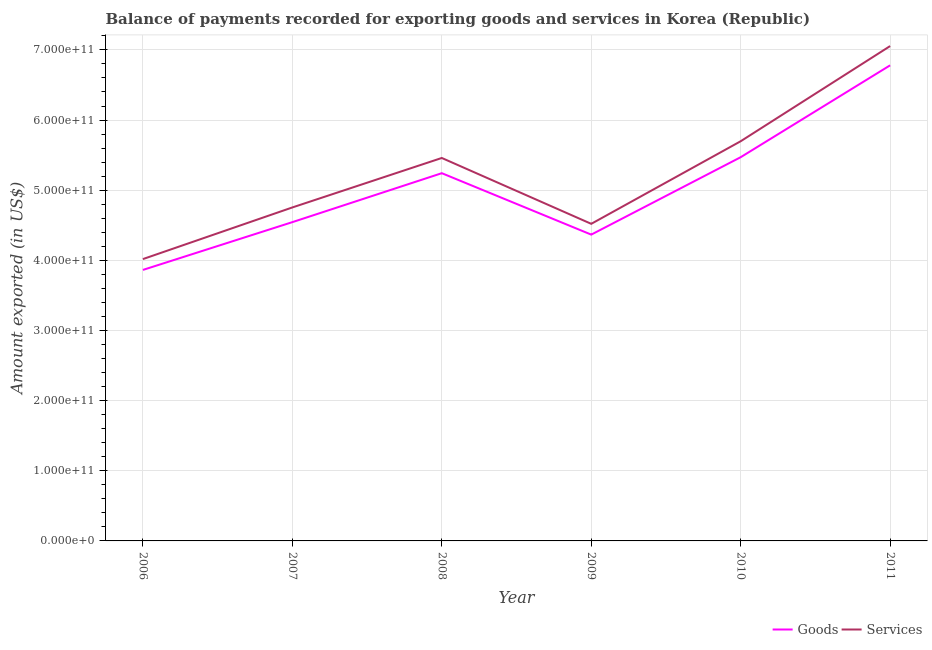Is the number of lines equal to the number of legend labels?
Your answer should be very brief. Yes. What is the amount of goods exported in 2008?
Your answer should be very brief. 5.24e+11. Across all years, what is the maximum amount of services exported?
Your response must be concise. 7.05e+11. Across all years, what is the minimum amount of services exported?
Provide a succinct answer. 4.02e+11. What is the total amount of services exported in the graph?
Your answer should be very brief. 3.15e+12. What is the difference between the amount of services exported in 2008 and that in 2011?
Your answer should be compact. -1.60e+11. What is the difference between the amount of services exported in 2010 and the amount of goods exported in 2009?
Give a very brief answer. 1.33e+11. What is the average amount of goods exported per year?
Make the answer very short. 5.04e+11. In the year 2006, what is the difference between the amount of services exported and amount of goods exported?
Offer a terse response. 1.55e+1. What is the ratio of the amount of services exported in 2006 to that in 2011?
Keep it short and to the point. 0.57. Is the difference between the amount of services exported in 2006 and 2009 greater than the difference between the amount of goods exported in 2006 and 2009?
Your answer should be very brief. Yes. What is the difference between the highest and the second highest amount of services exported?
Give a very brief answer. 1.36e+11. What is the difference between the highest and the lowest amount of goods exported?
Keep it short and to the point. 2.92e+11. In how many years, is the amount of goods exported greater than the average amount of goods exported taken over all years?
Provide a short and direct response. 3. Is the sum of the amount of goods exported in 2006 and 2011 greater than the maximum amount of services exported across all years?
Ensure brevity in your answer.  Yes. How many years are there in the graph?
Ensure brevity in your answer.  6. What is the difference between two consecutive major ticks on the Y-axis?
Your answer should be compact. 1.00e+11. Are the values on the major ticks of Y-axis written in scientific E-notation?
Provide a short and direct response. Yes. Does the graph contain grids?
Provide a short and direct response. Yes. Where does the legend appear in the graph?
Provide a succinct answer. Bottom right. What is the title of the graph?
Your response must be concise. Balance of payments recorded for exporting goods and services in Korea (Republic). What is the label or title of the Y-axis?
Make the answer very short. Amount exported (in US$). What is the Amount exported (in US$) of Goods in 2006?
Provide a short and direct response. 3.86e+11. What is the Amount exported (in US$) of Services in 2006?
Give a very brief answer. 4.02e+11. What is the Amount exported (in US$) of Goods in 2007?
Give a very brief answer. 4.54e+11. What is the Amount exported (in US$) of Services in 2007?
Provide a succinct answer. 4.75e+11. What is the Amount exported (in US$) in Goods in 2008?
Your response must be concise. 5.24e+11. What is the Amount exported (in US$) of Services in 2008?
Provide a short and direct response. 5.46e+11. What is the Amount exported (in US$) of Goods in 2009?
Make the answer very short. 4.37e+11. What is the Amount exported (in US$) of Services in 2009?
Keep it short and to the point. 4.52e+11. What is the Amount exported (in US$) of Goods in 2010?
Your response must be concise. 5.47e+11. What is the Amount exported (in US$) of Services in 2010?
Offer a terse response. 5.70e+11. What is the Amount exported (in US$) of Goods in 2011?
Provide a short and direct response. 6.78e+11. What is the Amount exported (in US$) in Services in 2011?
Keep it short and to the point. 7.05e+11. Across all years, what is the maximum Amount exported (in US$) of Goods?
Give a very brief answer. 6.78e+11. Across all years, what is the maximum Amount exported (in US$) in Services?
Offer a very short reply. 7.05e+11. Across all years, what is the minimum Amount exported (in US$) of Goods?
Your response must be concise. 3.86e+11. Across all years, what is the minimum Amount exported (in US$) of Services?
Offer a very short reply. 4.02e+11. What is the total Amount exported (in US$) of Goods in the graph?
Your response must be concise. 3.03e+12. What is the total Amount exported (in US$) in Services in the graph?
Keep it short and to the point. 3.15e+12. What is the difference between the Amount exported (in US$) in Goods in 2006 and that in 2007?
Your response must be concise. -6.81e+1. What is the difference between the Amount exported (in US$) of Services in 2006 and that in 2007?
Offer a very short reply. -7.36e+1. What is the difference between the Amount exported (in US$) in Goods in 2006 and that in 2008?
Keep it short and to the point. -1.38e+11. What is the difference between the Amount exported (in US$) in Services in 2006 and that in 2008?
Your answer should be compact. -1.44e+11. What is the difference between the Amount exported (in US$) in Goods in 2006 and that in 2009?
Provide a succinct answer. -5.03e+1. What is the difference between the Amount exported (in US$) of Services in 2006 and that in 2009?
Your answer should be compact. -5.03e+1. What is the difference between the Amount exported (in US$) of Goods in 2006 and that in 2010?
Offer a terse response. -1.61e+11. What is the difference between the Amount exported (in US$) in Services in 2006 and that in 2010?
Your answer should be very brief. -1.68e+11. What is the difference between the Amount exported (in US$) in Goods in 2006 and that in 2011?
Provide a short and direct response. -2.92e+11. What is the difference between the Amount exported (in US$) in Services in 2006 and that in 2011?
Give a very brief answer. -3.04e+11. What is the difference between the Amount exported (in US$) in Goods in 2007 and that in 2008?
Provide a short and direct response. -6.98e+1. What is the difference between the Amount exported (in US$) in Services in 2007 and that in 2008?
Offer a very short reply. -7.05e+1. What is the difference between the Amount exported (in US$) in Goods in 2007 and that in 2009?
Offer a terse response. 1.78e+1. What is the difference between the Amount exported (in US$) in Services in 2007 and that in 2009?
Keep it short and to the point. 2.34e+1. What is the difference between the Amount exported (in US$) of Goods in 2007 and that in 2010?
Provide a short and direct response. -9.26e+1. What is the difference between the Amount exported (in US$) in Services in 2007 and that in 2010?
Give a very brief answer. -9.44e+1. What is the difference between the Amount exported (in US$) of Goods in 2007 and that in 2011?
Your answer should be very brief. -2.24e+11. What is the difference between the Amount exported (in US$) in Services in 2007 and that in 2011?
Your answer should be very brief. -2.30e+11. What is the difference between the Amount exported (in US$) of Goods in 2008 and that in 2009?
Your response must be concise. 8.76e+1. What is the difference between the Amount exported (in US$) in Services in 2008 and that in 2009?
Give a very brief answer. 9.39e+1. What is the difference between the Amount exported (in US$) in Goods in 2008 and that in 2010?
Your response must be concise. -2.28e+1. What is the difference between the Amount exported (in US$) in Services in 2008 and that in 2010?
Ensure brevity in your answer.  -2.39e+1. What is the difference between the Amount exported (in US$) in Goods in 2008 and that in 2011?
Offer a terse response. -1.54e+11. What is the difference between the Amount exported (in US$) in Services in 2008 and that in 2011?
Your answer should be very brief. -1.60e+11. What is the difference between the Amount exported (in US$) of Goods in 2009 and that in 2010?
Keep it short and to the point. -1.10e+11. What is the difference between the Amount exported (in US$) of Services in 2009 and that in 2010?
Your response must be concise. -1.18e+11. What is the difference between the Amount exported (in US$) of Goods in 2009 and that in 2011?
Keep it short and to the point. -2.41e+11. What is the difference between the Amount exported (in US$) in Services in 2009 and that in 2011?
Your response must be concise. -2.53e+11. What is the difference between the Amount exported (in US$) of Goods in 2010 and that in 2011?
Offer a terse response. -1.31e+11. What is the difference between the Amount exported (in US$) in Services in 2010 and that in 2011?
Your answer should be very brief. -1.36e+11. What is the difference between the Amount exported (in US$) of Goods in 2006 and the Amount exported (in US$) of Services in 2007?
Provide a short and direct response. -8.91e+1. What is the difference between the Amount exported (in US$) in Goods in 2006 and the Amount exported (in US$) in Services in 2008?
Provide a succinct answer. -1.60e+11. What is the difference between the Amount exported (in US$) in Goods in 2006 and the Amount exported (in US$) in Services in 2009?
Your response must be concise. -6.57e+1. What is the difference between the Amount exported (in US$) in Goods in 2006 and the Amount exported (in US$) in Services in 2010?
Keep it short and to the point. -1.83e+11. What is the difference between the Amount exported (in US$) of Goods in 2006 and the Amount exported (in US$) of Services in 2011?
Ensure brevity in your answer.  -3.19e+11. What is the difference between the Amount exported (in US$) in Goods in 2007 and the Amount exported (in US$) in Services in 2008?
Your response must be concise. -9.15e+1. What is the difference between the Amount exported (in US$) of Goods in 2007 and the Amount exported (in US$) of Services in 2009?
Ensure brevity in your answer.  2.42e+09. What is the difference between the Amount exported (in US$) of Goods in 2007 and the Amount exported (in US$) of Services in 2010?
Make the answer very short. -1.15e+11. What is the difference between the Amount exported (in US$) of Goods in 2007 and the Amount exported (in US$) of Services in 2011?
Your answer should be very brief. -2.51e+11. What is the difference between the Amount exported (in US$) of Goods in 2008 and the Amount exported (in US$) of Services in 2009?
Provide a short and direct response. 7.22e+1. What is the difference between the Amount exported (in US$) of Goods in 2008 and the Amount exported (in US$) of Services in 2010?
Provide a succinct answer. -4.55e+1. What is the difference between the Amount exported (in US$) of Goods in 2008 and the Amount exported (in US$) of Services in 2011?
Offer a very short reply. -1.81e+11. What is the difference between the Amount exported (in US$) in Goods in 2009 and the Amount exported (in US$) in Services in 2010?
Provide a short and direct response. -1.33e+11. What is the difference between the Amount exported (in US$) of Goods in 2009 and the Amount exported (in US$) of Services in 2011?
Your answer should be compact. -2.69e+11. What is the difference between the Amount exported (in US$) in Goods in 2010 and the Amount exported (in US$) in Services in 2011?
Make the answer very short. -1.58e+11. What is the average Amount exported (in US$) of Goods per year?
Ensure brevity in your answer.  5.04e+11. What is the average Amount exported (in US$) in Services per year?
Offer a terse response. 5.25e+11. In the year 2006, what is the difference between the Amount exported (in US$) of Goods and Amount exported (in US$) of Services?
Your answer should be very brief. -1.55e+1. In the year 2007, what is the difference between the Amount exported (in US$) in Goods and Amount exported (in US$) in Services?
Offer a terse response. -2.09e+1. In the year 2008, what is the difference between the Amount exported (in US$) in Goods and Amount exported (in US$) in Services?
Make the answer very short. -2.17e+1. In the year 2009, what is the difference between the Amount exported (in US$) of Goods and Amount exported (in US$) of Services?
Give a very brief answer. -1.54e+1. In the year 2010, what is the difference between the Amount exported (in US$) in Goods and Amount exported (in US$) in Services?
Your answer should be compact. -2.27e+1. In the year 2011, what is the difference between the Amount exported (in US$) in Goods and Amount exported (in US$) in Services?
Provide a short and direct response. -2.74e+1. What is the ratio of the Amount exported (in US$) in Goods in 2006 to that in 2007?
Give a very brief answer. 0.85. What is the ratio of the Amount exported (in US$) in Services in 2006 to that in 2007?
Your answer should be very brief. 0.85. What is the ratio of the Amount exported (in US$) in Goods in 2006 to that in 2008?
Offer a very short reply. 0.74. What is the ratio of the Amount exported (in US$) of Services in 2006 to that in 2008?
Your answer should be compact. 0.74. What is the ratio of the Amount exported (in US$) in Goods in 2006 to that in 2009?
Offer a very short reply. 0.88. What is the ratio of the Amount exported (in US$) of Services in 2006 to that in 2009?
Offer a very short reply. 0.89. What is the ratio of the Amount exported (in US$) of Goods in 2006 to that in 2010?
Offer a terse response. 0.71. What is the ratio of the Amount exported (in US$) of Services in 2006 to that in 2010?
Offer a very short reply. 0.71. What is the ratio of the Amount exported (in US$) in Goods in 2006 to that in 2011?
Offer a terse response. 0.57. What is the ratio of the Amount exported (in US$) of Services in 2006 to that in 2011?
Offer a terse response. 0.57. What is the ratio of the Amount exported (in US$) of Goods in 2007 to that in 2008?
Your response must be concise. 0.87. What is the ratio of the Amount exported (in US$) of Services in 2007 to that in 2008?
Your answer should be compact. 0.87. What is the ratio of the Amount exported (in US$) of Goods in 2007 to that in 2009?
Your answer should be very brief. 1.04. What is the ratio of the Amount exported (in US$) in Services in 2007 to that in 2009?
Provide a succinct answer. 1.05. What is the ratio of the Amount exported (in US$) of Goods in 2007 to that in 2010?
Make the answer very short. 0.83. What is the ratio of the Amount exported (in US$) in Services in 2007 to that in 2010?
Ensure brevity in your answer.  0.83. What is the ratio of the Amount exported (in US$) of Goods in 2007 to that in 2011?
Give a very brief answer. 0.67. What is the ratio of the Amount exported (in US$) in Services in 2007 to that in 2011?
Offer a terse response. 0.67. What is the ratio of the Amount exported (in US$) of Goods in 2008 to that in 2009?
Ensure brevity in your answer.  1.2. What is the ratio of the Amount exported (in US$) in Services in 2008 to that in 2009?
Keep it short and to the point. 1.21. What is the ratio of the Amount exported (in US$) of Goods in 2008 to that in 2010?
Offer a very short reply. 0.96. What is the ratio of the Amount exported (in US$) in Services in 2008 to that in 2010?
Give a very brief answer. 0.96. What is the ratio of the Amount exported (in US$) in Goods in 2008 to that in 2011?
Give a very brief answer. 0.77. What is the ratio of the Amount exported (in US$) in Services in 2008 to that in 2011?
Offer a very short reply. 0.77. What is the ratio of the Amount exported (in US$) in Goods in 2009 to that in 2010?
Give a very brief answer. 0.8. What is the ratio of the Amount exported (in US$) in Services in 2009 to that in 2010?
Your response must be concise. 0.79. What is the ratio of the Amount exported (in US$) of Goods in 2009 to that in 2011?
Provide a succinct answer. 0.64. What is the ratio of the Amount exported (in US$) of Services in 2009 to that in 2011?
Provide a succinct answer. 0.64. What is the ratio of the Amount exported (in US$) in Goods in 2010 to that in 2011?
Keep it short and to the point. 0.81. What is the ratio of the Amount exported (in US$) in Services in 2010 to that in 2011?
Keep it short and to the point. 0.81. What is the difference between the highest and the second highest Amount exported (in US$) of Goods?
Provide a succinct answer. 1.31e+11. What is the difference between the highest and the second highest Amount exported (in US$) in Services?
Ensure brevity in your answer.  1.36e+11. What is the difference between the highest and the lowest Amount exported (in US$) of Goods?
Keep it short and to the point. 2.92e+11. What is the difference between the highest and the lowest Amount exported (in US$) in Services?
Provide a short and direct response. 3.04e+11. 